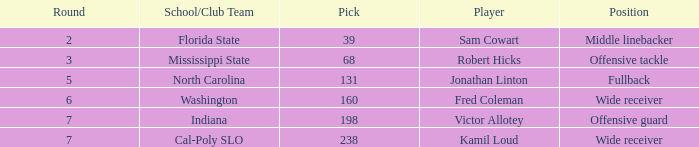Which Round has a School/Club Team of cal-poly slo, and a Pick smaller than 238? None. 